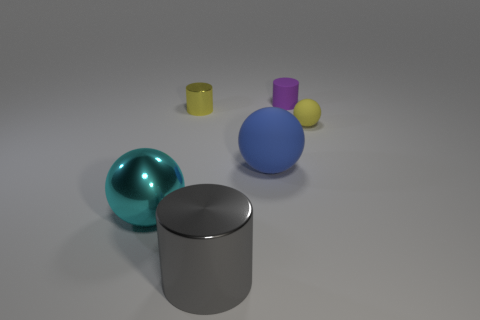How many balls are to the left of the tiny yellow rubber sphere?
Your response must be concise. 2. Are there fewer purple matte cylinders than small cyan metal balls?
Your answer should be compact. No. There is a thing that is both behind the yellow matte object and to the right of the gray metal thing; what size is it?
Your answer should be compact. Small. There is a tiny rubber thing that is in front of the small matte cylinder; is it the same color as the small metal cylinder?
Provide a short and direct response. Yes. Is the number of purple matte things that are left of the big cyan object less than the number of yellow matte things?
Your answer should be compact. Yes. The tiny yellow object that is made of the same material as the blue thing is what shape?
Your response must be concise. Sphere. Is the material of the big gray cylinder the same as the purple cylinder?
Make the answer very short. No. Are there fewer big blue matte objects behind the yellow metal cylinder than rubber spheres on the right side of the big gray metallic object?
Your answer should be very brief. Yes. There is a rubber thing that is the same color as the tiny metal object; what size is it?
Offer a very short reply. Small. There is a big metallic thing that is behind the shiny cylinder in front of the big cyan ball; how many metallic cylinders are in front of it?
Provide a short and direct response. 1. 